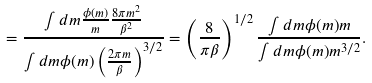<formula> <loc_0><loc_0><loc_500><loc_500>= \frac { \int d m \frac { \phi ( m ) } { m } \frac { 8 \pi m ^ { 2 } } { \beta ^ { 2 } } } { \int d m \phi ( m ) \left ( \frac { 2 \pi m } { \beta } \right ) ^ { 3 / 2 } } = \left ( \frac { 8 } { \pi \beta } \right ) ^ { 1 / 2 } \frac { \int d m \phi ( m ) m } { \int d m \phi ( m ) m ^ { 3 / 2 } } .</formula> 